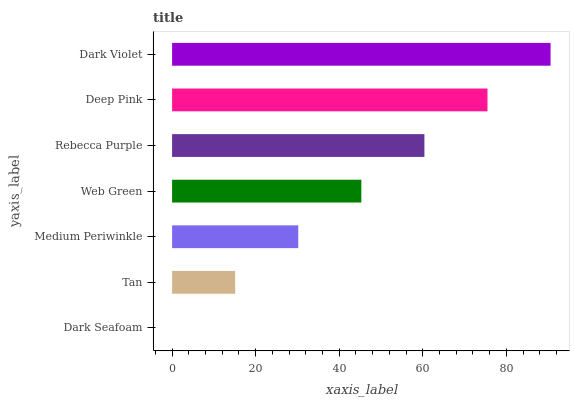Is Dark Seafoam the minimum?
Answer yes or no. Yes. Is Dark Violet the maximum?
Answer yes or no. Yes. Is Tan the minimum?
Answer yes or no. No. Is Tan the maximum?
Answer yes or no. No. Is Tan greater than Dark Seafoam?
Answer yes or no. Yes. Is Dark Seafoam less than Tan?
Answer yes or no. Yes. Is Dark Seafoam greater than Tan?
Answer yes or no. No. Is Tan less than Dark Seafoam?
Answer yes or no. No. Is Web Green the high median?
Answer yes or no. Yes. Is Web Green the low median?
Answer yes or no. Yes. Is Dark Violet the high median?
Answer yes or no. No. Is Deep Pink the low median?
Answer yes or no. No. 